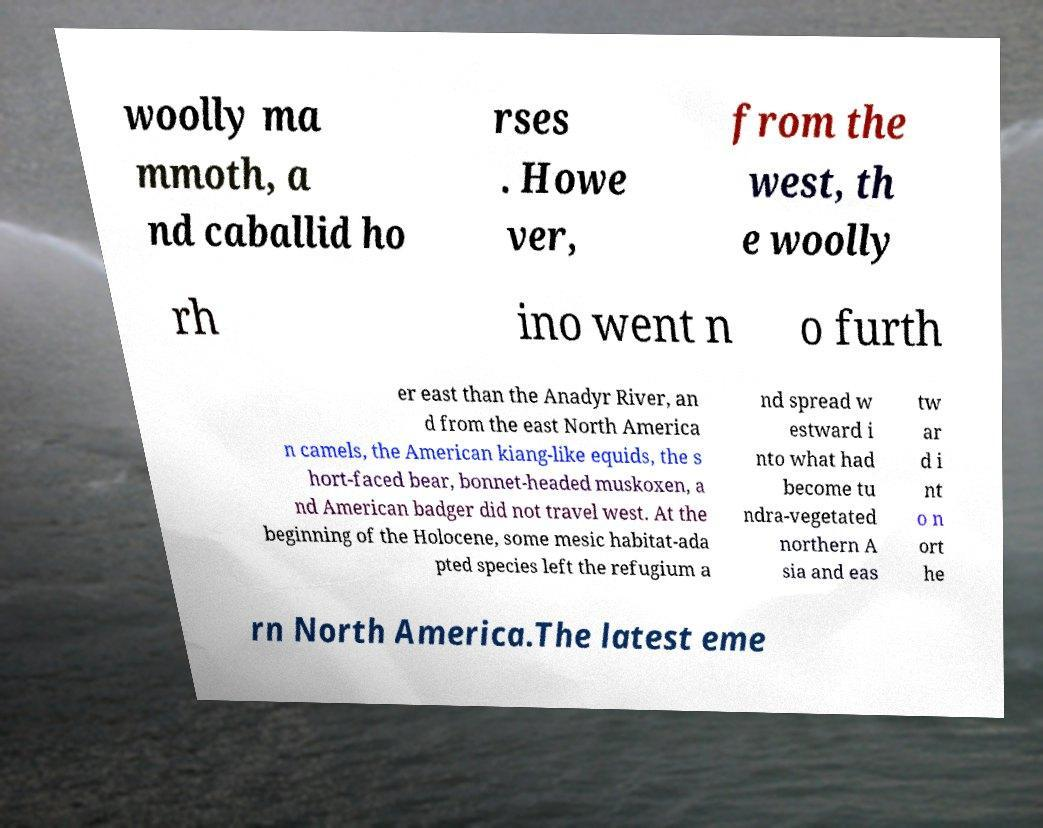Can you accurately transcribe the text from the provided image for me? woolly ma mmoth, a nd caballid ho rses . Howe ver, from the west, th e woolly rh ino went n o furth er east than the Anadyr River, an d from the east North America n camels, the American kiang-like equids, the s hort-faced bear, bonnet-headed muskoxen, a nd American badger did not travel west. At the beginning of the Holocene, some mesic habitat-ada pted species left the refugium a nd spread w estward i nto what had become tu ndra-vegetated northern A sia and eas tw ar d i nt o n ort he rn North America.The latest eme 